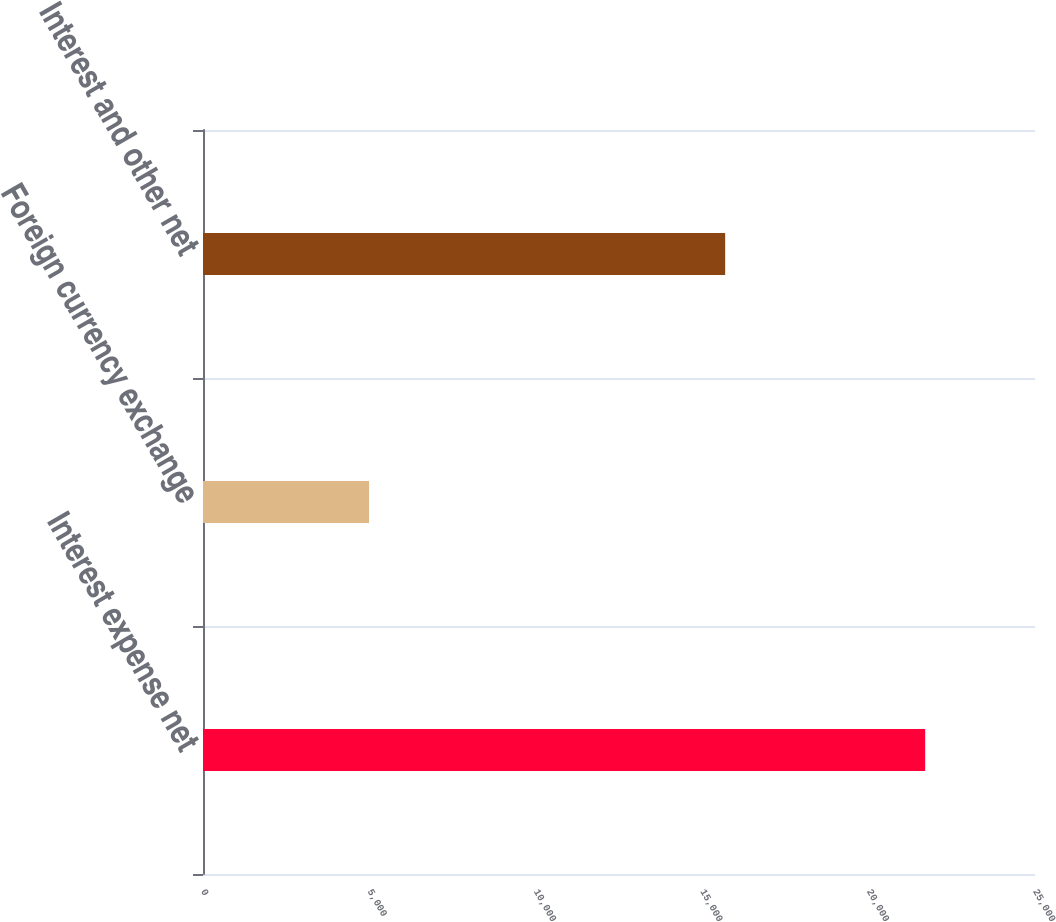Convert chart. <chart><loc_0><loc_0><loc_500><loc_500><bar_chart><fcel>Interest expense net<fcel>Foreign currency exchange<fcel>Interest and other net<nl><fcel>21700<fcel>4990<fcel>15690<nl></chart> 